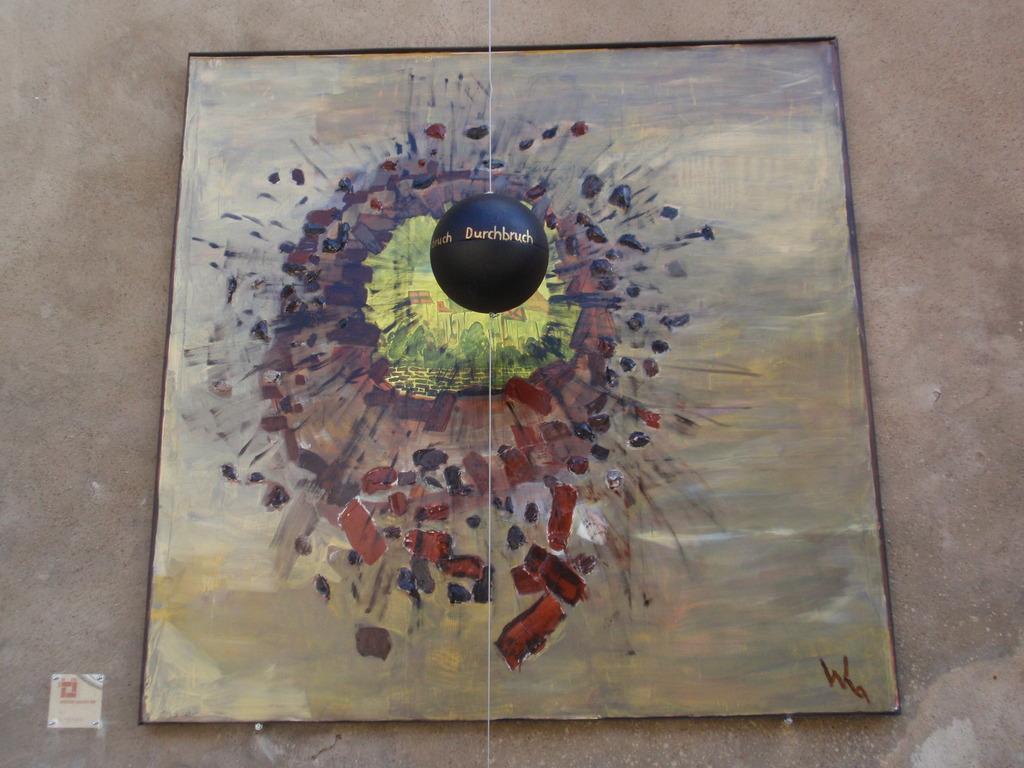Please provide a concise description of this image. In the image in the center we can see black ball and thread tied to it. In the background there is a wall and painting board. 